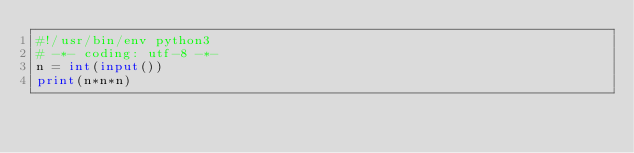<code> <loc_0><loc_0><loc_500><loc_500><_Python_>#!/usr/bin/env python3
# -*- coding: utf-8 -*-
n = int(input())
print(n*n*n)
</code> 